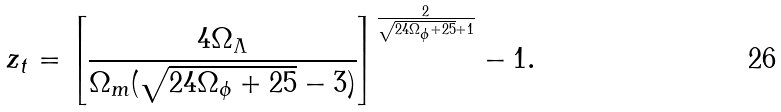<formula> <loc_0><loc_0><loc_500><loc_500>z _ { t } = \left [ \frac { 4 \Omega _ { \Lambda } } { \Omega _ { m } ( \sqrt { 2 4 \Omega _ { \phi } + 2 5 } - 3 ) } \right ] ^ { \frac { 2 } { \sqrt { 2 4 \Omega _ { \phi } + 2 5 } + 1 } } - 1 .</formula> 